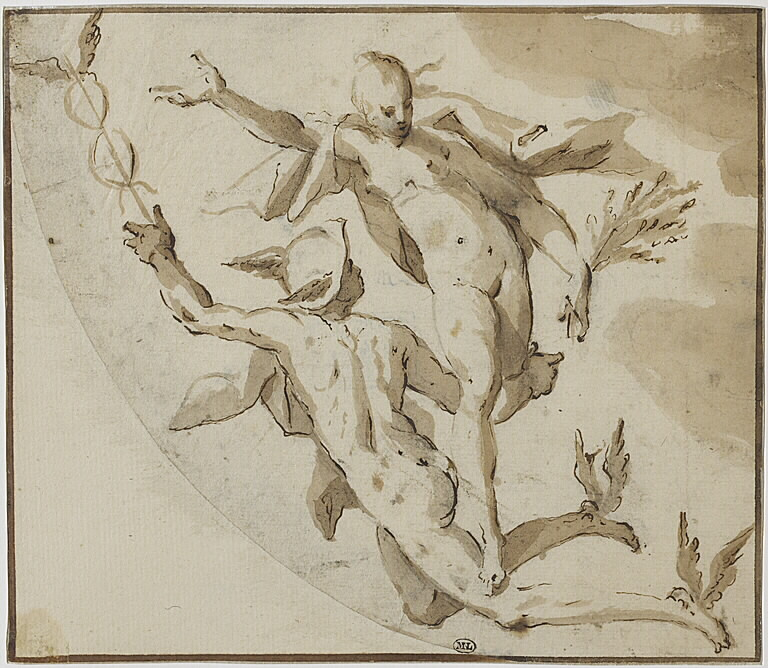Imagine this scene is part of an epic mythological tale. What mythological figures could these characters be, and what might their story entail? In an epic mythological tale, these figures could be representations of gods or heroes from ancient mythology. The male figure could be Hermes, the messenger god known for his speed and ability to traverse different realms, while the female could be Iris, the goddess of the rainbow and a messenger as well. Their story might involve a critical mission to deliver a divine message or save humanity from impending disaster. Hermes, with his winged sandals, supports Iris as they fly through the heavens, combining their strengths to overcome a formidable challenge. Their journey could embody themes of unity, divine intervention, and the harmonious balance of masculine and feminine forces. 